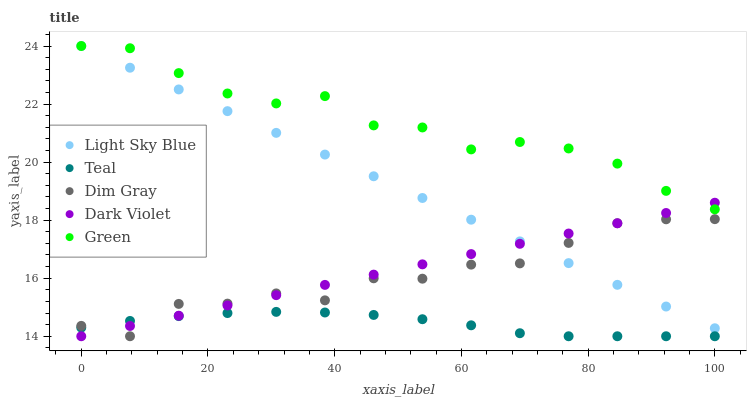Does Teal have the minimum area under the curve?
Answer yes or no. Yes. Does Green have the maximum area under the curve?
Answer yes or no. Yes. Does Light Sky Blue have the minimum area under the curve?
Answer yes or no. No. Does Light Sky Blue have the maximum area under the curve?
Answer yes or no. No. Is Light Sky Blue the smoothest?
Answer yes or no. Yes. Is Dim Gray the roughest?
Answer yes or no. Yes. Is Green the smoothest?
Answer yes or no. No. Is Green the roughest?
Answer yes or no. No. Does Dim Gray have the lowest value?
Answer yes or no. Yes. Does Light Sky Blue have the lowest value?
Answer yes or no. No. Does Green have the highest value?
Answer yes or no. Yes. Does Dark Violet have the highest value?
Answer yes or no. No. Is Dim Gray less than Green?
Answer yes or no. Yes. Is Green greater than Dim Gray?
Answer yes or no. Yes. Does Dark Violet intersect Dim Gray?
Answer yes or no. Yes. Is Dark Violet less than Dim Gray?
Answer yes or no. No. Is Dark Violet greater than Dim Gray?
Answer yes or no. No. Does Dim Gray intersect Green?
Answer yes or no. No. 